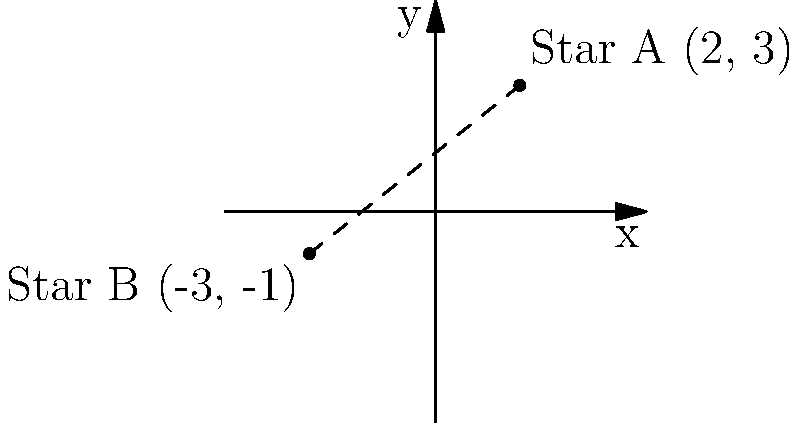A mechanical engineer is working on a telescope mount project and needs to calculate the distance between two celestial objects. On a star chart, Star A has coordinates (2, 3) and Star B has coordinates (-3, -1). What is the distance between these two stars on the chart? To solve this problem, we'll use the distance formula derived from the Pythagorean theorem:

$d = \sqrt{(x_2 - x_1)^2 + (y_2 - y_1)^2}$

Where $(x_1, y_1)$ are the coordinates of Star A and $(x_2, y_2)$ are the coordinates of Star B.

Step 1: Identify the coordinates
Star A: $(x_1, y_1) = (2, 3)$
Star B: $(x_2, y_2) = (-3, -1)$

Step 2: Plug the coordinates into the distance formula
$d = \sqrt{(-3 - 2)^2 + (-1 - 3)^2}$

Step 3: Simplify the expressions inside the parentheses
$d = \sqrt{(-5)^2 + (-4)^2}$

Step 4: Calculate the squares
$d = \sqrt{25 + 16}$

Step 5: Add the values under the square root
$d = \sqrt{41}$

Step 6: Simplify the square root (if possible)
In this case, $\sqrt{41}$ cannot be simplified further.

Therefore, the distance between Star A and Star B on the star chart is $\sqrt{41}$ units.
Answer: $\sqrt{41}$ units 